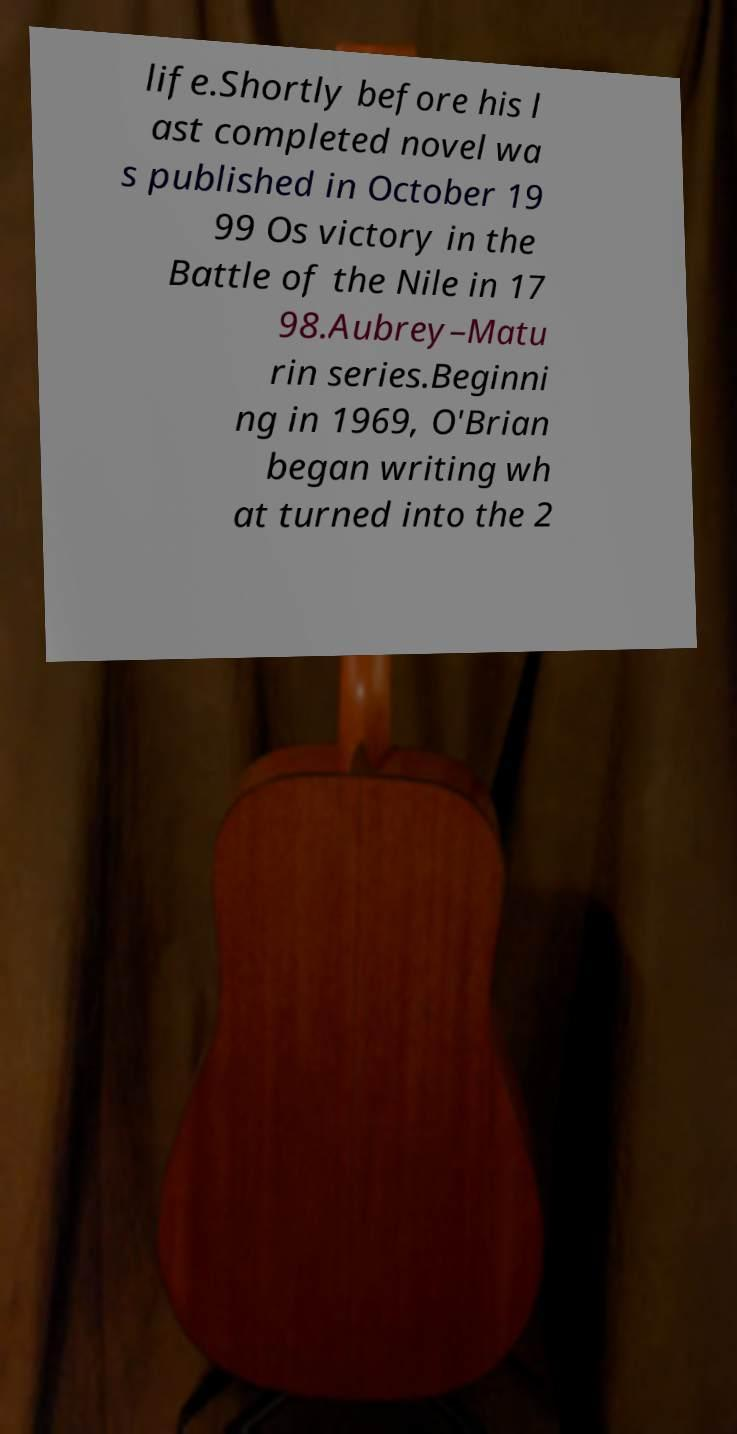Could you extract and type out the text from this image? life.Shortly before his l ast completed novel wa s published in October 19 99 Os victory in the Battle of the Nile in 17 98.Aubrey–Matu rin series.Beginni ng in 1969, O'Brian began writing wh at turned into the 2 